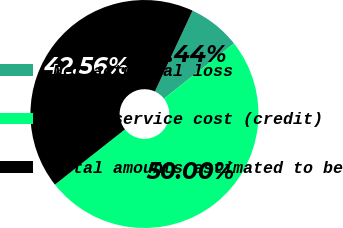Convert chart to OTSL. <chart><loc_0><loc_0><loc_500><loc_500><pie_chart><fcel>Net actuarial loss<fcel>Prior service cost (credit)<fcel>Total amounts estimated to be<nl><fcel>7.44%<fcel>50.0%<fcel>42.56%<nl></chart> 